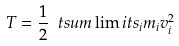<formula> <loc_0><loc_0><loc_500><loc_500>T = \frac { 1 } { 2 } \ t s u m \lim i t s _ { i } m _ { i } v _ { i } ^ { 2 }</formula> 